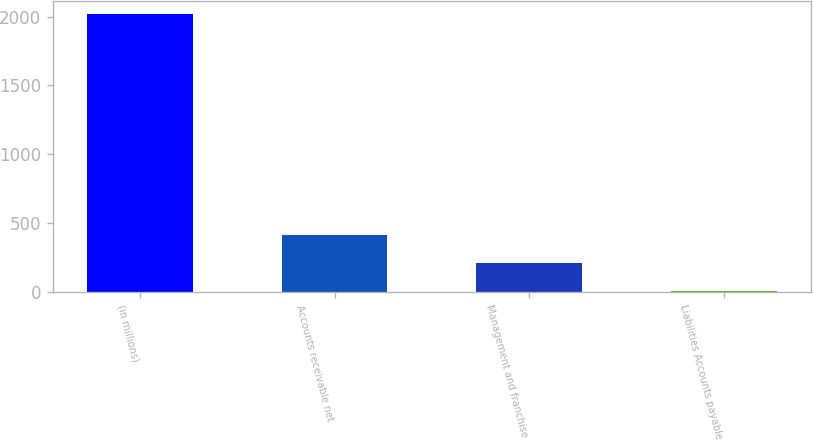Convert chart to OTSL. <chart><loc_0><loc_0><loc_500><loc_500><bar_chart><fcel>(in millions)<fcel>Accounts receivable net<fcel>Management and franchise<fcel>Liabilities Accounts payable<nl><fcel>2015<fcel>410.2<fcel>209.6<fcel>9<nl></chart> 